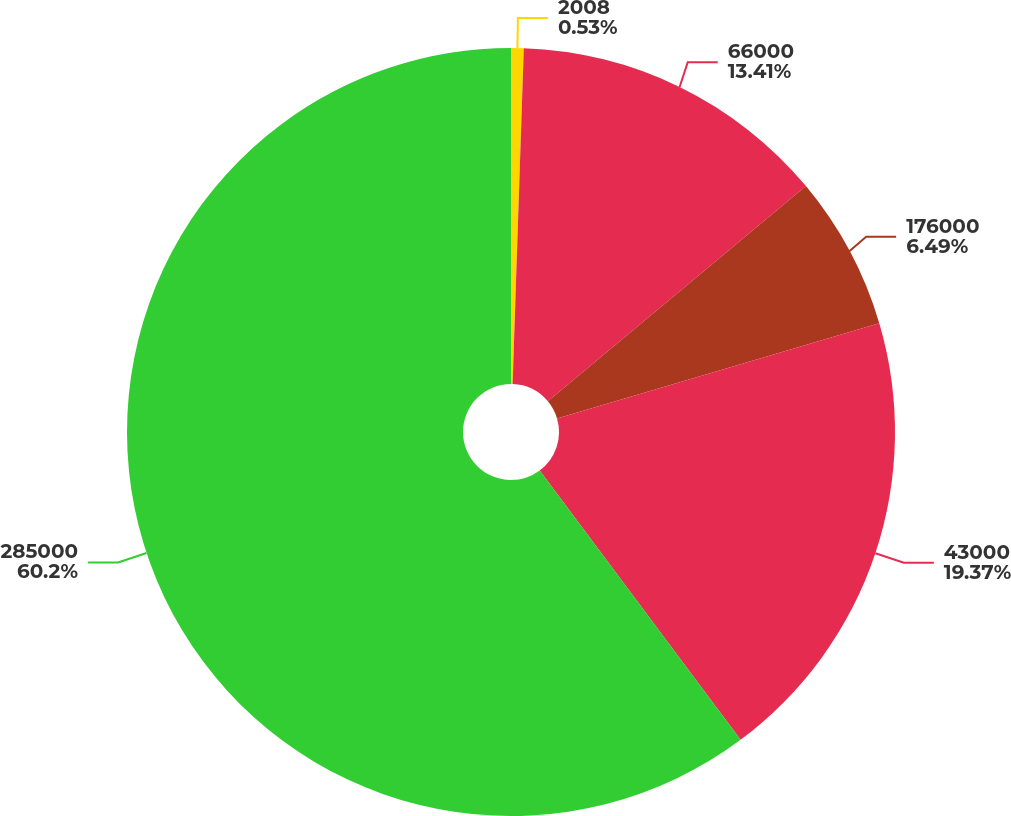Convert chart to OTSL. <chart><loc_0><loc_0><loc_500><loc_500><pie_chart><fcel>2008<fcel>66000<fcel>176000<fcel>43000<fcel>285000<nl><fcel>0.53%<fcel>13.41%<fcel>6.49%<fcel>19.37%<fcel>60.2%<nl></chart> 